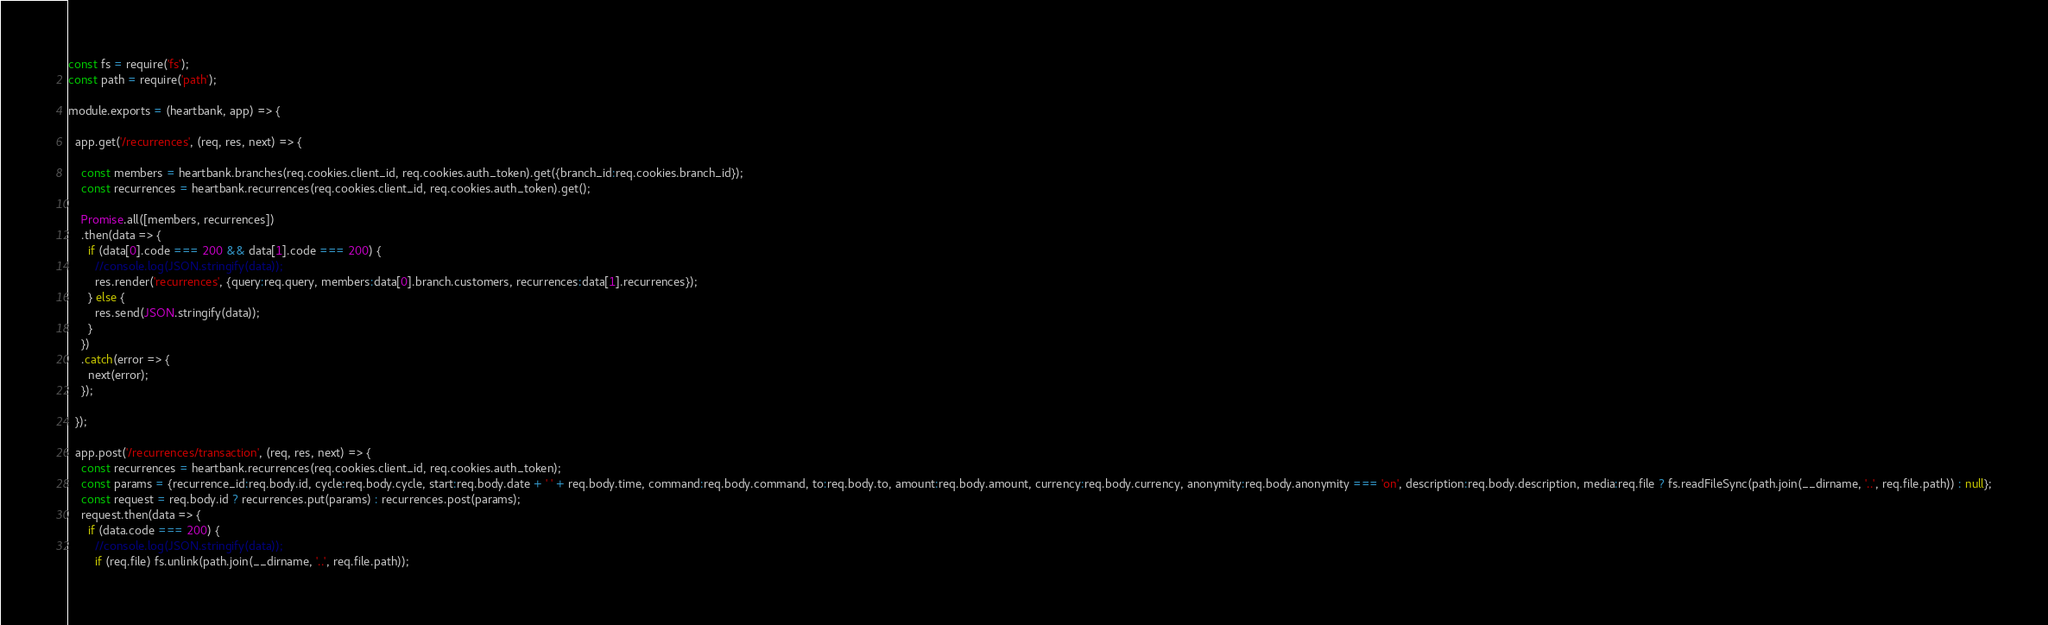<code> <loc_0><loc_0><loc_500><loc_500><_JavaScript_>const fs = require('fs');
const path = require('path');

module.exports = (heartbank, app) => {

  app.get('/recurrences', (req, res, next) => {

    const members = heartbank.branches(req.cookies.client_id, req.cookies.auth_token).get({branch_id:req.cookies.branch_id});
    const recurrences = heartbank.recurrences(req.cookies.client_id, req.cookies.auth_token).get();

    Promise.all([members, recurrences])
    .then(data => {
      if (data[0].code === 200 && data[1].code === 200) {
        //console.log(JSON.stringify(data));
        res.render('recurrences', {query:req.query, members:data[0].branch.customers, recurrences:data[1].recurrences});
      } else {
        res.send(JSON.stringify(data));
      }
    })
    .catch(error => {
      next(error);
    });

  });

  app.post('/recurrences/transaction', (req, res, next) => {
    const recurrences = heartbank.recurrences(req.cookies.client_id, req.cookies.auth_token);
    const params = {recurrence_id:req.body.id, cycle:req.body.cycle, start:req.body.date + ' ' + req.body.time, command:req.body.command, to:req.body.to, amount:req.body.amount, currency:req.body.currency, anonymity:req.body.anonymity === 'on', description:req.body.description, media:req.file ? fs.readFileSync(path.join(__dirname, '..', req.file.path)) : null};
    const request = req.body.id ? recurrences.put(params) : recurrences.post(params);
    request.then(data => {
      if (data.code === 200) {
        //console.log(JSON.stringify(data));
        if (req.file) fs.unlink(path.join(__dirname, '..', req.file.path));</code> 